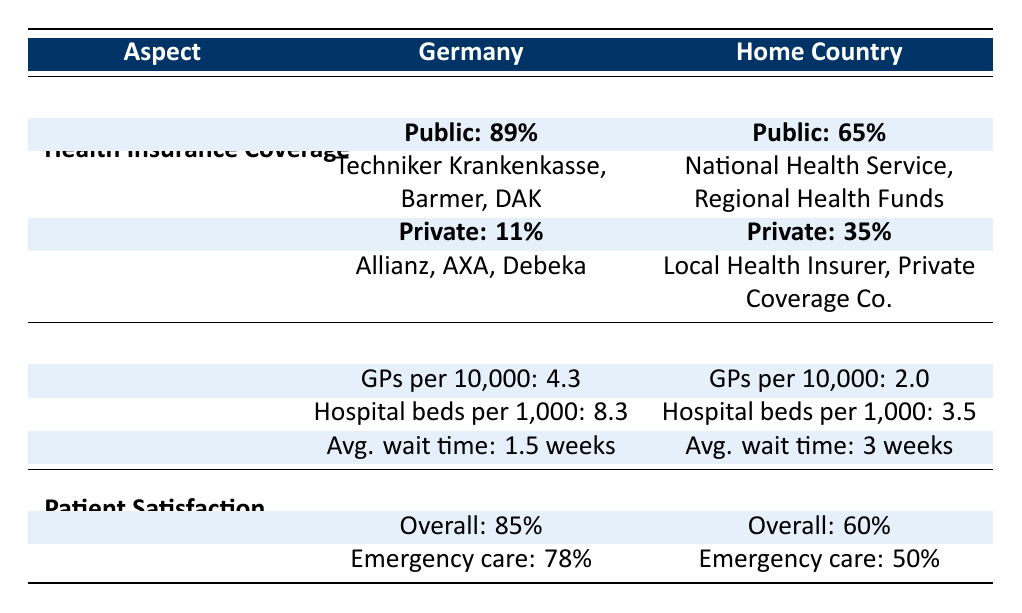What is the percentage of the population covered by public health insurance in Germany? The table shows that the percentage of the population covered by public health insurance in Germany is indicated under the "Health Insurance Coverage" section. Specifically, it states that 89% of the population is covered by public insurance.
Answer: 89% What are the common providers of public health insurance in the home country? According to the "Health Insurance Coverage" section, under public insurance for the home country, it lists "National Health Service" and "Regional Health Funds" as common providers.
Answer: National Health Service, Regional Health Funds How many general practitioners are available per 10,000 people in the home country? The table under the "Access To Care" section specifies that there are 2.0 general practitioners per 10,000 people in the home country.
Answer: 2.0 Is the overall satisfaction rate for patients higher in Germany compared to the home country? The overall satisfaction rate for patients in Germany is 85%, while in the home country it is 60%. Since 85% is greater than 60%, the statement is true.
Answer: Yes What is the difference in the number of hospital beds per 1,000 between Germany and the home country? The table shows that Germany has 8.3 hospital beds per 1,000, while the home country has 3.5 hospital beds per 1,000. To calculate the difference, subtract 3.5 from 8.3, which gives us 8.3 - 3.5 = 4.8.
Answer: 4.8 Are patients more satisfied with emergency care in the home country than in Germany? The satisfaction rate for emergency care in Germany is 78%, while in the home country, it is 50%. Since 78% is greater than 50%, patients are actually more satisfied in Germany.
Answer: No What is the average wait time for an appointment in both Germany and the home country combined? According to the table, the average wait time in Germany is 1.5 weeks and in the home country, it is 3 weeks. To calculate the average, sum these times (1.5 + 3 = 4.5 weeks) and then divide by 2, giving us 4.5 / 2 = 2.25 weeks.
Answer: 2.25 weeks Which country has a higher percentage of private insurance coverage, and what are the percentages? The table indicates that the home country has a higher percentage (35%) of private insurance coverage compared to Germany (11%). Here, the home country has more private insurance coverage.
Answer: Home country: 35%, Germany: 11% How many more hospital beds are available per 1,000 in Germany compared to the home country? According to the data, Germany has 8.3 hospital beds per 1,000, while the home country has 3.5. So, to find how many more beds are available, subtract the home country’s number from Germany’s: 8.3 - 3.5 = 4.8 beds.
Answer: 4.8 beds What is the overall satisfaction rate in Germany compared to the home country? The overall satisfaction rate in Germany is 85%, while it is 60% in the home country. Since 85% is greater than 60%, it shows that overall satisfaction is higher in Germany.
Answer: Higher in Germany 